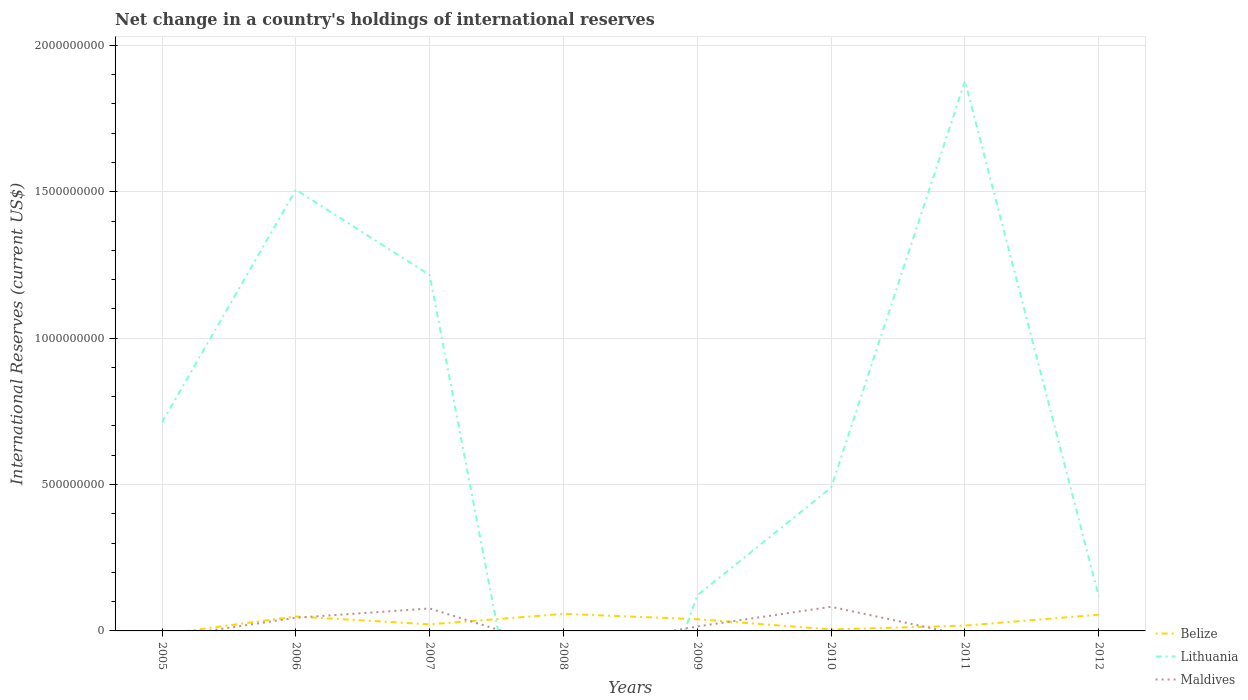Does the line corresponding to Lithuania intersect with the line corresponding to Belize?
Keep it short and to the point. Yes. What is the total international reserves in Belize in the graph?
Your answer should be very brief. 3.11e+07. What is the difference between the highest and the second highest international reserves in Belize?
Ensure brevity in your answer.  5.82e+07. Is the international reserves in Belize strictly greater than the international reserves in Lithuania over the years?
Your answer should be very brief. No. What is the difference between two consecutive major ticks on the Y-axis?
Your answer should be compact. 5.00e+08. Does the graph contain grids?
Make the answer very short. Yes. Where does the legend appear in the graph?
Your response must be concise. Bottom right. How many legend labels are there?
Provide a short and direct response. 3. What is the title of the graph?
Offer a very short reply. Net change in a country's holdings of international reserves. Does "European Union" appear as one of the legend labels in the graph?
Make the answer very short. No. What is the label or title of the Y-axis?
Your answer should be very brief. International Reserves (current US$). What is the International Reserves (current US$) of Belize in 2005?
Your response must be concise. 0. What is the International Reserves (current US$) of Lithuania in 2005?
Give a very brief answer. 7.12e+08. What is the International Reserves (current US$) in Maldives in 2005?
Make the answer very short. 0. What is the International Reserves (current US$) in Belize in 2006?
Your response must be concise. 4.93e+07. What is the International Reserves (current US$) of Lithuania in 2006?
Give a very brief answer. 1.51e+09. What is the International Reserves (current US$) of Maldives in 2006?
Offer a very short reply. 4.50e+07. What is the International Reserves (current US$) of Belize in 2007?
Keep it short and to the point. 2.24e+07. What is the International Reserves (current US$) of Lithuania in 2007?
Provide a succinct answer. 1.22e+09. What is the International Reserves (current US$) of Maldives in 2007?
Provide a short and direct response. 7.67e+07. What is the International Reserves (current US$) in Belize in 2008?
Provide a short and direct response. 5.82e+07. What is the International Reserves (current US$) of Maldives in 2008?
Provide a short and direct response. 0. What is the International Reserves (current US$) in Belize in 2009?
Your answer should be compact. 4.00e+07. What is the International Reserves (current US$) in Lithuania in 2009?
Your answer should be very brief. 1.22e+08. What is the International Reserves (current US$) of Maldives in 2009?
Give a very brief answer. 1.54e+07. What is the International Reserves (current US$) in Belize in 2010?
Your answer should be very brief. 4.99e+06. What is the International Reserves (current US$) of Lithuania in 2010?
Give a very brief answer. 4.89e+08. What is the International Reserves (current US$) in Maldives in 2010?
Give a very brief answer. 8.23e+07. What is the International Reserves (current US$) in Belize in 2011?
Keep it short and to the point. 1.82e+07. What is the International Reserves (current US$) in Lithuania in 2011?
Keep it short and to the point. 1.88e+09. What is the International Reserves (current US$) of Belize in 2012?
Keep it short and to the point. 5.55e+07. What is the International Reserves (current US$) in Lithuania in 2012?
Offer a terse response. 1.18e+08. Across all years, what is the maximum International Reserves (current US$) in Belize?
Your answer should be very brief. 5.82e+07. Across all years, what is the maximum International Reserves (current US$) in Lithuania?
Provide a succinct answer. 1.88e+09. Across all years, what is the maximum International Reserves (current US$) of Maldives?
Ensure brevity in your answer.  8.23e+07. Across all years, what is the minimum International Reserves (current US$) of Lithuania?
Offer a very short reply. 0. Across all years, what is the minimum International Reserves (current US$) in Maldives?
Your answer should be very brief. 0. What is the total International Reserves (current US$) of Belize in the graph?
Ensure brevity in your answer.  2.49e+08. What is the total International Reserves (current US$) of Lithuania in the graph?
Your answer should be compact. 6.04e+09. What is the total International Reserves (current US$) in Maldives in the graph?
Your answer should be very brief. 2.19e+08. What is the difference between the International Reserves (current US$) in Lithuania in 2005 and that in 2006?
Make the answer very short. -7.94e+08. What is the difference between the International Reserves (current US$) in Lithuania in 2005 and that in 2007?
Provide a succinct answer. -5.03e+08. What is the difference between the International Reserves (current US$) of Lithuania in 2005 and that in 2009?
Offer a terse response. 5.91e+08. What is the difference between the International Reserves (current US$) in Lithuania in 2005 and that in 2010?
Your response must be concise. 2.23e+08. What is the difference between the International Reserves (current US$) in Lithuania in 2005 and that in 2011?
Make the answer very short. -1.17e+09. What is the difference between the International Reserves (current US$) in Lithuania in 2005 and that in 2012?
Your answer should be very brief. 5.94e+08. What is the difference between the International Reserves (current US$) in Belize in 2006 and that in 2007?
Make the answer very short. 2.69e+07. What is the difference between the International Reserves (current US$) of Lithuania in 2006 and that in 2007?
Keep it short and to the point. 2.91e+08. What is the difference between the International Reserves (current US$) of Maldives in 2006 and that in 2007?
Your answer should be compact. -3.17e+07. What is the difference between the International Reserves (current US$) of Belize in 2006 and that in 2008?
Your answer should be very brief. -8.85e+06. What is the difference between the International Reserves (current US$) in Belize in 2006 and that in 2009?
Offer a terse response. 9.32e+06. What is the difference between the International Reserves (current US$) in Lithuania in 2006 and that in 2009?
Provide a succinct answer. 1.39e+09. What is the difference between the International Reserves (current US$) in Maldives in 2006 and that in 2009?
Your answer should be very brief. 2.96e+07. What is the difference between the International Reserves (current US$) of Belize in 2006 and that in 2010?
Your response must be concise. 4.44e+07. What is the difference between the International Reserves (current US$) of Lithuania in 2006 and that in 2010?
Make the answer very short. 1.02e+09. What is the difference between the International Reserves (current US$) in Maldives in 2006 and that in 2010?
Make the answer very short. -3.74e+07. What is the difference between the International Reserves (current US$) in Belize in 2006 and that in 2011?
Provide a short and direct response. 3.11e+07. What is the difference between the International Reserves (current US$) in Lithuania in 2006 and that in 2011?
Make the answer very short. -3.71e+08. What is the difference between the International Reserves (current US$) of Belize in 2006 and that in 2012?
Provide a succinct answer. -6.11e+06. What is the difference between the International Reserves (current US$) of Lithuania in 2006 and that in 2012?
Provide a succinct answer. 1.39e+09. What is the difference between the International Reserves (current US$) in Belize in 2007 and that in 2008?
Ensure brevity in your answer.  -3.58e+07. What is the difference between the International Reserves (current US$) in Belize in 2007 and that in 2009?
Offer a very short reply. -1.76e+07. What is the difference between the International Reserves (current US$) of Lithuania in 2007 and that in 2009?
Provide a short and direct response. 1.09e+09. What is the difference between the International Reserves (current US$) of Maldives in 2007 and that in 2009?
Your response must be concise. 6.13e+07. What is the difference between the International Reserves (current US$) in Belize in 2007 and that in 2010?
Provide a short and direct response. 1.74e+07. What is the difference between the International Reserves (current US$) in Lithuania in 2007 and that in 2010?
Keep it short and to the point. 7.26e+08. What is the difference between the International Reserves (current US$) of Maldives in 2007 and that in 2010?
Your answer should be very brief. -5.64e+06. What is the difference between the International Reserves (current US$) of Belize in 2007 and that in 2011?
Ensure brevity in your answer.  4.22e+06. What is the difference between the International Reserves (current US$) in Lithuania in 2007 and that in 2011?
Offer a very short reply. -6.62e+08. What is the difference between the International Reserves (current US$) in Belize in 2007 and that in 2012?
Ensure brevity in your answer.  -3.30e+07. What is the difference between the International Reserves (current US$) in Lithuania in 2007 and that in 2012?
Give a very brief answer. 1.10e+09. What is the difference between the International Reserves (current US$) of Belize in 2008 and that in 2009?
Make the answer very short. 1.82e+07. What is the difference between the International Reserves (current US$) in Belize in 2008 and that in 2010?
Keep it short and to the point. 5.32e+07. What is the difference between the International Reserves (current US$) in Belize in 2008 and that in 2011?
Offer a terse response. 4.00e+07. What is the difference between the International Reserves (current US$) in Belize in 2008 and that in 2012?
Offer a very short reply. 2.74e+06. What is the difference between the International Reserves (current US$) of Belize in 2009 and that in 2010?
Your answer should be compact. 3.50e+07. What is the difference between the International Reserves (current US$) in Lithuania in 2009 and that in 2010?
Offer a terse response. -3.68e+08. What is the difference between the International Reserves (current US$) of Maldives in 2009 and that in 2010?
Give a very brief answer. -6.70e+07. What is the difference between the International Reserves (current US$) of Belize in 2009 and that in 2011?
Provide a short and direct response. 2.18e+07. What is the difference between the International Reserves (current US$) in Lithuania in 2009 and that in 2011?
Make the answer very short. -1.76e+09. What is the difference between the International Reserves (current US$) in Belize in 2009 and that in 2012?
Your answer should be compact. -1.54e+07. What is the difference between the International Reserves (current US$) in Lithuania in 2009 and that in 2012?
Ensure brevity in your answer.  3.38e+06. What is the difference between the International Reserves (current US$) of Belize in 2010 and that in 2011?
Make the answer very short. -1.32e+07. What is the difference between the International Reserves (current US$) in Lithuania in 2010 and that in 2011?
Provide a succinct answer. -1.39e+09. What is the difference between the International Reserves (current US$) in Belize in 2010 and that in 2012?
Provide a succinct answer. -5.05e+07. What is the difference between the International Reserves (current US$) in Lithuania in 2010 and that in 2012?
Ensure brevity in your answer.  3.71e+08. What is the difference between the International Reserves (current US$) in Belize in 2011 and that in 2012?
Provide a short and direct response. -3.72e+07. What is the difference between the International Reserves (current US$) in Lithuania in 2011 and that in 2012?
Offer a very short reply. 1.76e+09. What is the difference between the International Reserves (current US$) of Lithuania in 2005 and the International Reserves (current US$) of Maldives in 2006?
Provide a short and direct response. 6.67e+08. What is the difference between the International Reserves (current US$) in Lithuania in 2005 and the International Reserves (current US$) in Maldives in 2007?
Keep it short and to the point. 6.36e+08. What is the difference between the International Reserves (current US$) of Lithuania in 2005 and the International Reserves (current US$) of Maldives in 2009?
Provide a succinct answer. 6.97e+08. What is the difference between the International Reserves (current US$) in Lithuania in 2005 and the International Reserves (current US$) in Maldives in 2010?
Ensure brevity in your answer.  6.30e+08. What is the difference between the International Reserves (current US$) in Belize in 2006 and the International Reserves (current US$) in Lithuania in 2007?
Keep it short and to the point. -1.17e+09. What is the difference between the International Reserves (current US$) of Belize in 2006 and the International Reserves (current US$) of Maldives in 2007?
Offer a very short reply. -2.74e+07. What is the difference between the International Reserves (current US$) of Lithuania in 2006 and the International Reserves (current US$) of Maldives in 2007?
Your answer should be compact. 1.43e+09. What is the difference between the International Reserves (current US$) of Belize in 2006 and the International Reserves (current US$) of Lithuania in 2009?
Keep it short and to the point. -7.22e+07. What is the difference between the International Reserves (current US$) of Belize in 2006 and the International Reserves (current US$) of Maldives in 2009?
Give a very brief answer. 3.40e+07. What is the difference between the International Reserves (current US$) of Lithuania in 2006 and the International Reserves (current US$) of Maldives in 2009?
Keep it short and to the point. 1.49e+09. What is the difference between the International Reserves (current US$) of Belize in 2006 and the International Reserves (current US$) of Lithuania in 2010?
Provide a succinct answer. -4.40e+08. What is the difference between the International Reserves (current US$) of Belize in 2006 and the International Reserves (current US$) of Maldives in 2010?
Your response must be concise. -3.30e+07. What is the difference between the International Reserves (current US$) in Lithuania in 2006 and the International Reserves (current US$) in Maldives in 2010?
Offer a terse response. 1.42e+09. What is the difference between the International Reserves (current US$) in Belize in 2006 and the International Reserves (current US$) in Lithuania in 2011?
Give a very brief answer. -1.83e+09. What is the difference between the International Reserves (current US$) in Belize in 2006 and the International Reserves (current US$) in Lithuania in 2012?
Keep it short and to the point. -6.88e+07. What is the difference between the International Reserves (current US$) in Belize in 2007 and the International Reserves (current US$) in Lithuania in 2009?
Ensure brevity in your answer.  -9.91e+07. What is the difference between the International Reserves (current US$) in Belize in 2007 and the International Reserves (current US$) in Maldives in 2009?
Your response must be concise. 7.05e+06. What is the difference between the International Reserves (current US$) of Lithuania in 2007 and the International Reserves (current US$) of Maldives in 2009?
Your response must be concise. 1.20e+09. What is the difference between the International Reserves (current US$) of Belize in 2007 and the International Reserves (current US$) of Lithuania in 2010?
Your answer should be compact. -4.67e+08. What is the difference between the International Reserves (current US$) in Belize in 2007 and the International Reserves (current US$) in Maldives in 2010?
Provide a short and direct response. -5.99e+07. What is the difference between the International Reserves (current US$) in Lithuania in 2007 and the International Reserves (current US$) in Maldives in 2010?
Provide a succinct answer. 1.13e+09. What is the difference between the International Reserves (current US$) of Belize in 2007 and the International Reserves (current US$) of Lithuania in 2011?
Ensure brevity in your answer.  -1.86e+09. What is the difference between the International Reserves (current US$) in Belize in 2007 and the International Reserves (current US$) in Lithuania in 2012?
Offer a very short reply. -9.57e+07. What is the difference between the International Reserves (current US$) of Belize in 2008 and the International Reserves (current US$) of Lithuania in 2009?
Your response must be concise. -6.33e+07. What is the difference between the International Reserves (current US$) of Belize in 2008 and the International Reserves (current US$) of Maldives in 2009?
Keep it short and to the point. 4.28e+07. What is the difference between the International Reserves (current US$) of Belize in 2008 and the International Reserves (current US$) of Lithuania in 2010?
Offer a very short reply. -4.31e+08. What is the difference between the International Reserves (current US$) in Belize in 2008 and the International Reserves (current US$) in Maldives in 2010?
Give a very brief answer. -2.42e+07. What is the difference between the International Reserves (current US$) of Belize in 2008 and the International Reserves (current US$) of Lithuania in 2011?
Provide a short and direct response. -1.82e+09. What is the difference between the International Reserves (current US$) of Belize in 2008 and the International Reserves (current US$) of Lithuania in 2012?
Provide a short and direct response. -5.99e+07. What is the difference between the International Reserves (current US$) in Belize in 2009 and the International Reserves (current US$) in Lithuania in 2010?
Make the answer very short. -4.49e+08. What is the difference between the International Reserves (current US$) of Belize in 2009 and the International Reserves (current US$) of Maldives in 2010?
Ensure brevity in your answer.  -4.23e+07. What is the difference between the International Reserves (current US$) in Lithuania in 2009 and the International Reserves (current US$) in Maldives in 2010?
Provide a succinct answer. 3.92e+07. What is the difference between the International Reserves (current US$) in Belize in 2009 and the International Reserves (current US$) in Lithuania in 2011?
Make the answer very short. -1.84e+09. What is the difference between the International Reserves (current US$) of Belize in 2009 and the International Reserves (current US$) of Lithuania in 2012?
Provide a short and direct response. -7.81e+07. What is the difference between the International Reserves (current US$) in Belize in 2010 and the International Reserves (current US$) in Lithuania in 2011?
Offer a terse response. -1.87e+09. What is the difference between the International Reserves (current US$) in Belize in 2010 and the International Reserves (current US$) in Lithuania in 2012?
Make the answer very short. -1.13e+08. What is the difference between the International Reserves (current US$) in Belize in 2011 and the International Reserves (current US$) in Lithuania in 2012?
Your response must be concise. -9.99e+07. What is the average International Reserves (current US$) of Belize per year?
Give a very brief answer. 3.11e+07. What is the average International Reserves (current US$) of Lithuania per year?
Offer a very short reply. 7.55e+08. What is the average International Reserves (current US$) of Maldives per year?
Your response must be concise. 2.74e+07. In the year 2006, what is the difference between the International Reserves (current US$) of Belize and International Reserves (current US$) of Lithuania?
Ensure brevity in your answer.  -1.46e+09. In the year 2006, what is the difference between the International Reserves (current US$) in Belize and International Reserves (current US$) in Maldives?
Offer a very short reply. 4.37e+06. In the year 2006, what is the difference between the International Reserves (current US$) of Lithuania and International Reserves (current US$) of Maldives?
Provide a succinct answer. 1.46e+09. In the year 2007, what is the difference between the International Reserves (current US$) in Belize and International Reserves (current US$) in Lithuania?
Give a very brief answer. -1.19e+09. In the year 2007, what is the difference between the International Reserves (current US$) of Belize and International Reserves (current US$) of Maldives?
Your response must be concise. -5.43e+07. In the year 2007, what is the difference between the International Reserves (current US$) in Lithuania and International Reserves (current US$) in Maldives?
Provide a succinct answer. 1.14e+09. In the year 2009, what is the difference between the International Reserves (current US$) of Belize and International Reserves (current US$) of Lithuania?
Give a very brief answer. -8.15e+07. In the year 2009, what is the difference between the International Reserves (current US$) in Belize and International Reserves (current US$) in Maldives?
Make the answer very short. 2.47e+07. In the year 2009, what is the difference between the International Reserves (current US$) in Lithuania and International Reserves (current US$) in Maldives?
Offer a very short reply. 1.06e+08. In the year 2010, what is the difference between the International Reserves (current US$) of Belize and International Reserves (current US$) of Lithuania?
Provide a short and direct response. -4.84e+08. In the year 2010, what is the difference between the International Reserves (current US$) in Belize and International Reserves (current US$) in Maldives?
Provide a short and direct response. -7.74e+07. In the year 2010, what is the difference between the International Reserves (current US$) in Lithuania and International Reserves (current US$) in Maldives?
Your answer should be compact. 4.07e+08. In the year 2011, what is the difference between the International Reserves (current US$) of Belize and International Reserves (current US$) of Lithuania?
Offer a very short reply. -1.86e+09. In the year 2012, what is the difference between the International Reserves (current US$) in Belize and International Reserves (current US$) in Lithuania?
Make the answer very short. -6.27e+07. What is the ratio of the International Reserves (current US$) in Lithuania in 2005 to that in 2006?
Keep it short and to the point. 0.47. What is the ratio of the International Reserves (current US$) in Lithuania in 2005 to that in 2007?
Provide a succinct answer. 0.59. What is the ratio of the International Reserves (current US$) of Lithuania in 2005 to that in 2009?
Your response must be concise. 5.86. What is the ratio of the International Reserves (current US$) in Lithuania in 2005 to that in 2010?
Your response must be concise. 1.46. What is the ratio of the International Reserves (current US$) in Lithuania in 2005 to that in 2011?
Offer a very short reply. 0.38. What is the ratio of the International Reserves (current US$) in Lithuania in 2005 to that in 2012?
Provide a succinct answer. 6.03. What is the ratio of the International Reserves (current US$) in Lithuania in 2006 to that in 2007?
Offer a terse response. 1.24. What is the ratio of the International Reserves (current US$) in Maldives in 2006 to that in 2007?
Your answer should be very brief. 0.59. What is the ratio of the International Reserves (current US$) in Belize in 2006 to that in 2008?
Your answer should be very brief. 0.85. What is the ratio of the International Reserves (current US$) of Belize in 2006 to that in 2009?
Keep it short and to the point. 1.23. What is the ratio of the International Reserves (current US$) of Lithuania in 2006 to that in 2009?
Keep it short and to the point. 12.4. What is the ratio of the International Reserves (current US$) of Maldives in 2006 to that in 2009?
Ensure brevity in your answer.  2.92. What is the ratio of the International Reserves (current US$) of Belize in 2006 to that in 2010?
Your answer should be compact. 9.88. What is the ratio of the International Reserves (current US$) in Lithuania in 2006 to that in 2010?
Provide a short and direct response. 3.08. What is the ratio of the International Reserves (current US$) in Maldives in 2006 to that in 2010?
Your response must be concise. 0.55. What is the ratio of the International Reserves (current US$) in Belize in 2006 to that in 2011?
Provide a short and direct response. 2.71. What is the ratio of the International Reserves (current US$) in Lithuania in 2006 to that in 2011?
Ensure brevity in your answer.  0.8. What is the ratio of the International Reserves (current US$) in Belize in 2006 to that in 2012?
Make the answer very short. 0.89. What is the ratio of the International Reserves (current US$) of Lithuania in 2006 to that in 2012?
Ensure brevity in your answer.  12.76. What is the ratio of the International Reserves (current US$) of Belize in 2007 to that in 2008?
Your answer should be compact. 0.39. What is the ratio of the International Reserves (current US$) in Belize in 2007 to that in 2009?
Give a very brief answer. 0.56. What is the ratio of the International Reserves (current US$) in Lithuania in 2007 to that in 2009?
Ensure brevity in your answer.  10.01. What is the ratio of the International Reserves (current US$) in Maldives in 2007 to that in 2009?
Provide a succinct answer. 4.99. What is the ratio of the International Reserves (current US$) in Belize in 2007 to that in 2010?
Give a very brief answer. 4.49. What is the ratio of the International Reserves (current US$) in Lithuania in 2007 to that in 2010?
Offer a terse response. 2.48. What is the ratio of the International Reserves (current US$) in Maldives in 2007 to that in 2010?
Give a very brief answer. 0.93. What is the ratio of the International Reserves (current US$) in Belize in 2007 to that in 2011?
Your response must be concise. 1.23. What is the ratio of the International Reserves (current US$) in Lithuania in 2007 to that in 2011?
Give a very brief answer. 0.65. What is the ratio of the International Reserves (current US$) in Belize in 2007 to that in 2012?
Your answer should be compact. 0.4. What is the ratio of the International Reserves (current US$) of Lithuania in 2007 to that in 2012?
Offer a very short reply. 10.29. What is the ratio of the International Reserves (current US$) in Belize in 2008 to that in 2009?
Provide a short and direct response. 1.45. What is the ratio of the International Reserves (current US$) of Belize in 2008 to that in 2010?
Offer a terse response. 11.66. What is the ratio of the International Reserves (current US$) in Belize in 2008 to that in 2011?
Provide a short and direct response. 3.2. What is the ratio of the International Reserves (current US$) in Belize in 2008 to that in 2012?
Provide a succinct answer. 1.05. What is the ratio of the International Reserves (current US$) of Belize in 2009 to that in 2010?
Keep it short and to the point. 8.02. What is the ratio of the International Reserves (current US$) in Lithuania in 2009 to that in 2010?
Your answer should be compact. 0.25. What is the ratio of the International Reserves (current US$) in Maldives in 2009 to that in 2010?
Make the answer very short. 0.19. What is the ratio of the International Reserves (current US$) of Belize in 2009 to that in 2011?
Your response must be concise. 2.2. What is the ratio of the International Reserves (current US$) in Lithuania in 2009 to that in 2011?
Ensure brevity in your answer.  0.06. What is the ratio of the International Reserves (current US$) in Belize in 2009 to that in 2012?
Provide a short and direct response. 0.72. What is the ratio of the International Reserves (current US$) of Lithuania in 2009 to that in 2012?
Keep it short and to the point. 1.03. What is the ratio of the International Reserves (current US$) of Belize in 2010 to that in 2011?
Offer a very short reply. 0.27. What is the ratio of the International Reserves (current US$) of Lithuania in 2010 to that in 2011?
Keep it short and to the point. 0.26. What is the ratio of the International Reserves (current US$) of Belize in 2010 to that in 2012?
Your answer should be compact. 0.09. What is the ratio of the International Reserves (current US$) in Lithuania in 2010 to that in 2012?
Offer a very short reply. 4.14. What is the ratio of the International Reserves (current US$) of Belize in 2011 to that in 2012?
Ensure brevity in your answer.  0.33. What is the ratio of the International Reserves (current US$) in Lithuania in 2011 to that in 2012?
Offer a terse response. 15.9. What is the difference between the highest and the second highest International Reserves (current US$) in Belize?
Make the answer very short. 2.74e+06. What is the difference between the highest and the second highest International Reserves (current US$) of Lithuania?
Offer a terse response. 3.71e+08. What is the difference between the highest and the second highest International Reserves (current US$) in Maldives?
Keep it short and to the point. 5.64e+06. What is the difference between the highest and the lowest International Reserves (current US$) in Belize?
Offer a terse response. 5.82e+07. What is the difference between the highest and the lowest International Reserves (current US$) of Lithuania?
Your response must be concise. 1.88e+09. What is the difference between the highest and the lowest International Reserves (current US$) of Maldives?
Make the answer very short. 8.23e+07. 